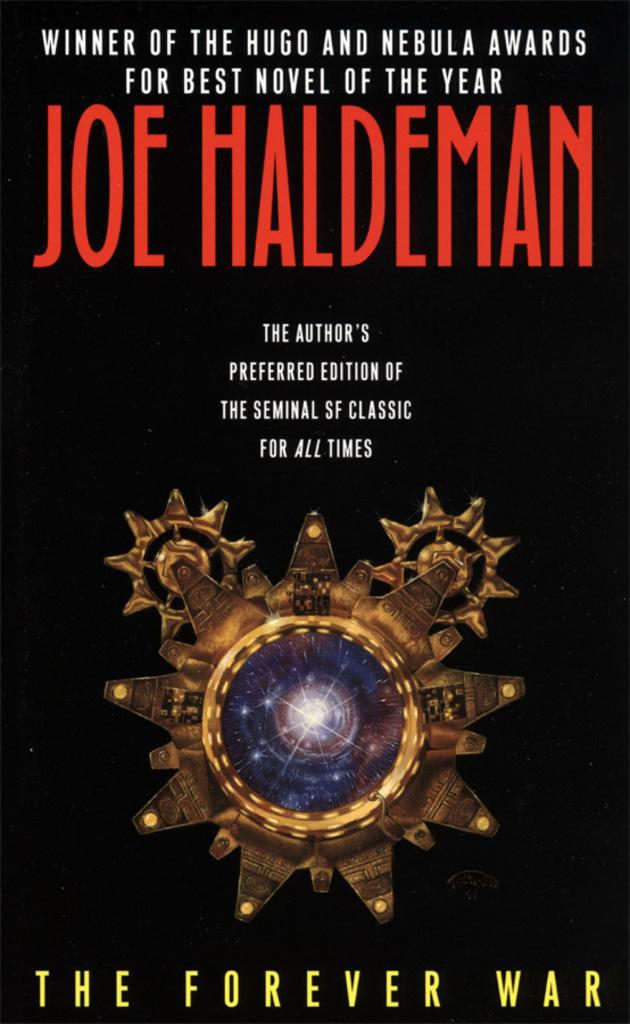<image>
Relay a brief, clear account of the picture shown. Joe Haldeman's book, The Forever War has a black cover and a gold object in the center. 